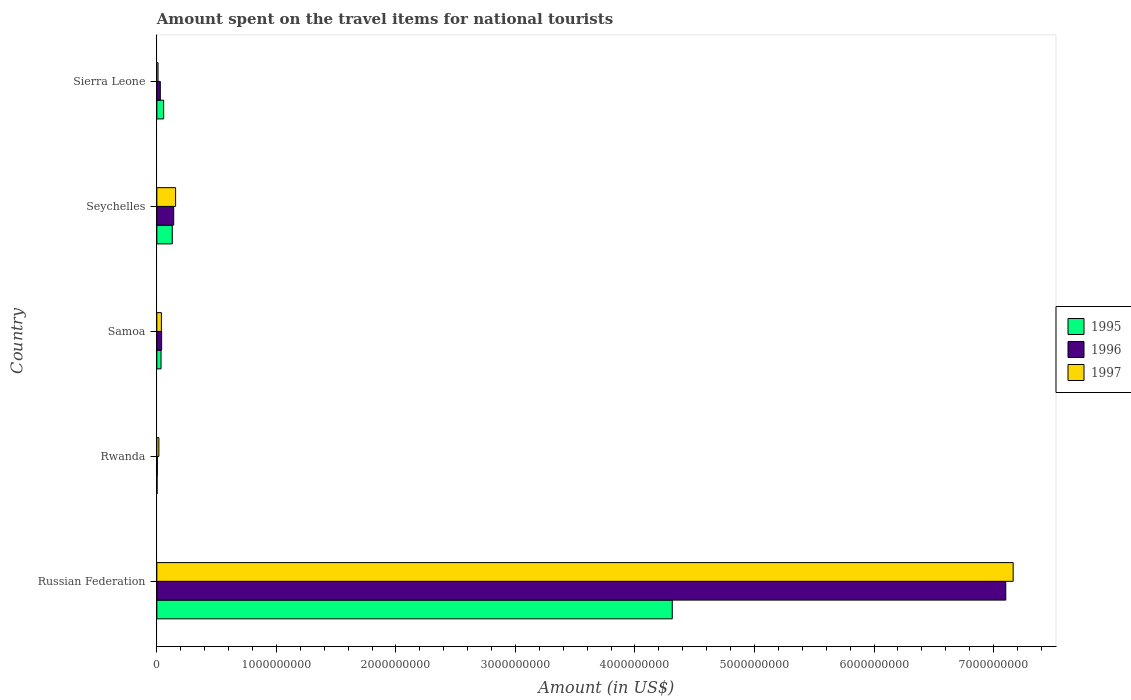What is the label of the 5th group of bars from the top?
Offer a very short reply. Russian Federation. What is the amount spent on the travel items for national tourists in 1996 in Seychelles?
Provide a short and direct response. 1.41e+08. Across all countries, what is the maximum amount spent on the travel items for national tourists in 1995?
Your response must be concise. 4.31e+09. Across all countries, what is the minimum amount spent on the travel items for national tourists in 1996?
Ensure brevity in your answer.  4.00e+06. In which country was the amount spent on the travel items for national tourists in 1995 maximum?
Make the answer very short. Russian Federation. In which country was the amount spent on the travel items for national tourists in 1996 minimum?
Your answer should be compact. Rwanda. What is the total amount spent on the travel items for national tourists in 1995 in the graph?
Make the answer very short. 4.54e+09. What is the difference between the amount spent on the travel items for national tourists in 1997 in Seychelles and that in Sierra Leone?
Your answer should be compact. 1.47e+08. What is the difference between the amount spent on the travel items for national tourists in 1997 in Samoa and the amount spent on the travel items for national tourists in 1996 in Seychelles?
Make the answer very short. -1.03e+08. What is the average amount spent on the travel items for national tourists in 1997 per country?
Your answer should be very brief. 1.48e+09. What is the difference between the amount spent on the travel items for national tourists in 1996 and amount spent on the travel items for national tourists in 1997 in Rwanda?
Your answer should be very brief. -1.30e+07. What is the ratio of the amount spent on the travel items for national tourists in 1996 in Russian Federation to that in Seychelles?
Offer a terse response. 50.37. What is the difference between the highest and the second highest amount spent on the travel items for national tourists in 1997?
Give a very brief answer. 7.01e+09. What is the difference between the highest and the lowest amount spent on the travel items for national tourists in 1995?
Provide a short and direct response. 4.31e+09. In how many countries, is the amount spent on the travel items for national tourists in 1997 greater than the average amount spent on the travel items for national tourists in 1997 taken over all countries?
Your answer should be compact. 1. Is the sum of the amount spent on the travel items for national tourists in 1996 in Russian Federation and Rwanda greater than the maximum amount spent on the travel items for national tourists in 1995 across all countries?
Your answer should be compact. Yes. What does the 2nd bar from the top in Seychelles represents?
Your answer should be very brief. 1996. What does the 2nd bar from the bottom in Samoa represents?
Your response must be concise. 1996. Is it the case that in every country, the sum of the amount spent on the travel items for national tourists in 1996 and amount spent on the travel items for national tourists in 1997 is greater than the amount spent on the travel items for national tourists in 1995?
Your answer should be very brief. No. Are all the bars in the graph horizontal?
Your answer should be very brief. Yes. Are the values on the major ticks of X-axis written in scientific E-notation?
Your response must be concise. No. How many legend labels are there?
Ensure brevity in your answer.  3. What is the title of the graph?
Offer a terse response. Amount spent on the travel items for national tourists. What is the Amount (in US$) of 1995 in Russian Federation?
Ensure brevity in your answer.  4.31e+09. What is the Amount (in US$) of 1996 in Russian Federation?
Your answer should be compact. 7.10e+09. What is the Amount (in US$) of 1997 in Russian Federation?
Provide a short and direct response. 7.16e+09. What is the Amount (in US$) in 1995 in Rwanda?
Make the answer very short. 2.00e+06. What is the Amount (in US$) of 1997 in Rwanda?
Your answer should be compact. 1.70e+07. What is the Amount (in US$) in 1995 in Samoa?
Give a very brief answer. 3.50e+07. What is the Amount (in US$) in 1996 in Samoa?
Make the answer very short. 4.00e+07. What is the Amount (in US$) in 1997 in Samoa?
Your answer should be compact. 3.80e+07. What is the Amount (in US$) of 1995 in Seychelles?
Provide a short and direct response. 1.29e+08. What is the Amount (in US$) in 1996 in Seychelles?
Your answer should be very brief. 1.41e+08. What is the Amount (in US$) of 1997 in Seychelles?
Give a very brief answer. 1.57e+08. What is the Amount (in US$) of 1995 in Sierra Leone?
Provide a short and direct response. 5.70e+07. What is the Amount (in US$) of 1996 in Sierra Leone?
Your answer should be compact. 2.90e+07. Across all countries, what is the maximum Amount (in US$) of 1995?
Your response must be concise. 4.31e+09. Across all countries, what is the maximum Amount (in US$) of 1996?
Your answer should be compact. 7.10e+09. Across all countries, what is the maximum Amount (in US$) in 1997?
Give a very brief answer. 7.16e+09. Across all countries, what is the minimum Amount (in US$) of 1996?
Ensure brevity in your answer.  4.00e+06. What is the total Amount (in US$) in 1995 in the graph?
Provide a short and direct response. 4.54e+09. What is the total Amount (in US$) of 1996 in the graph?
Provide a succinct answer. 7.32e+09. What is the total Amount (in US$) in 1997 in the graph?
Your response must be concise. 7.39e+09. What is the difference between the Amount (in US$) in 1995 in Russian Federation and that in Rwanda?
Provide a succinct answer. 4.31e+09. What is the difference between the Amount (in US$) in 1996 in Russian Federation and that in Rwanda?
Make the answer very short. 7.10e+09. What is the difference between the Amount (in US$) in 1997 in Russian Federation and that in Rwanda?
Keep it short and to the point. 7.15e+09. What is the difference between the Amount (in US$) in 1995 in Russian Federation and that in Samoa?
Your response must be concise. 4.28e+09. What is the difference between the Amount (in US$) in 1996 in Russian Federation and that in Samoa?
Give a very brief answer. 7.06e+09. What is the difference between the Amount (in US$) of 1997 in Russian Federation and that in Samoa?
Provide a short and direct response. 7.13e+09. What is the difference between the Amount (in US$) of 1995 in Russian Federation and that in Seychelles?
Provide a short and direct response. 4.18e+09. What is the difference between the Amount (in US$) of 1996 in Russian Federation and that in Seychelles?
Ensure brevity in your answer.  6.96e+09. What is the difference between the Amount (in US$) in 1997 in Russian Federation and that in Seychelles?
Keep it short and to the point. 7.01e+09. What is the difference between the Amount (in US$) in 1995 in Russian Federation and that in Sierra Leone?
Give a very brief answer. 4.26e+09. What is the difference between the Amount (in US$) of 1996 in Russian Federation and that in Sierra Leone?
Provide a short and direct response. 7.07e+09. What is the difference between the Amount (in US$) in 1997 in Russian Federation and that in Sierra Leone?
Offer a very short reply. 7.15e+09. What is the difference between the Amount (in US$) in 1995 in Rwanda and that in Samoa?
Make the answer very short. -3.30e+07. What is the difference between the Amount (in US$) of 1996 in Rwanda and that in Samoa?
Your answer should be very brief. -3.60e+07. What is the difference between the Amount (in US$) of 1997 in Rwanda and that in Samoa?
Provide a succinct answer. -2.10e+07. What is the difference between the Amount (in US$) of 1995 in Rwanda and that in Seychelles?
Keep it short and to the point. -1.27e+08. What is the difference between the Amount (in US$) of 1996 in Rwanda and that in Seychelles?
Give a very brief answer. -1.37e+08. What is the difference between the Amount (in US$) in 1997 in Rwanda and that in Seychelles?
Provide a succinct answer. -1.40e+08. What is the difference between the Amount (in US$) of 1995 in Rwanda and that in Sierra Leone?
Give a very brief answer. -5.50e+07. What is the difference between the Amount (in US$) in 1996 in Rwanda and that in Sierra Leone?
Your response must be concise. -2.50e+07. What is the difference between the Amount (in US$) of 1995 in Samoa and that in Seychelles?
Offer a terse response. -9.40e+07. What is the difference between the Amount (in US$) in 1996 in Samoa and that in Seychelles?
Your answer should be very brief. -1.01e+08. What is the difference between the Amount (in US$) in 1997 in Samoa and that in Seychelles?
Give a very brief answer. -1.19e+08. What is the difference between the Amount (in US$) in 1995 in Samoa and that in Sierra Leone?
Offer a terse response. -2.20e+07. What is the difference between the Amount (in US$) in 1996 in Samoa and that in Sierra Leone?
Offer a terse response. 1.10e+07. What is the difference between the Amount (in US$) in 1997 in Samoa and that in Sierra Leone?
Offer a terse response. 2.80e+07. What is the difference between the Amount (in US$) in 1995 in Seychelles and that in Sierra Leone?
Keep it short and to the point. 7.20e+07. What is the difference between the Amount (in US$) of 1996 in Seychelles and that in Sierra Leone?
Your answer should be compact. 1.12e+08. What is the difference between the Amount (in US$) in 1997 in Seychelles and that in Sierra Leone?
Offer a very short reply. 1.47e+08. What is the difference between the Amount (in US$) in 1995 in Russian Federation and the Amount (in US$) in 1996 in Rwanda?
Give a very brief answer. 4.31e+09. What is the difference between the Amount (in US$) of 1995 in Russian Federation and the Amount (in US$) of 1997 in Rwanda?
Provide a succinct answer. 4.30e+09. What is the difference between the Amount (in US$) in 1996 in Russian Federation and the Amount (in US$) in 1997 in Rwanda?
Offer a terse response. 7.08e+09. What is the difference between the Amount (in US$) in 1995 in Russian Federation and the Amount (in US$) in 1996 in Samoa?
Offer a very short reply. 4.27e+09. What is the difference between the Amount (in US$) of 1995 in Russian Federation and the Amount (in US$) of 1997 in Samoa?
Your answer should be very brief. 4.27e+09. What is the difference between the Amount (in US$) of 1996 in Russian Federation and the Amount (in US$) of 1997 in Samoa?
Keep it short and to the point. 7.06e+09. What is the difference between the Amount (in US$) in 1995 in Russian Federation and the Amount (in US$) in 1996 in Seychelles?
Ensure brevity in your answer.  4.17e+09. What is the difference between the Amount (in US$) in 1995 in Russian Federation and the Amount (in US$) in 1997 in Seychelles?
Offer a very short reply. 4.16e+09. What is the difference between the Amount (in US$) in 1996 in Russian Federation and the Amount (in US$) in 1997 in Seychelles?
Ensure brevity in your answer.  6.94e+09. What is the difference between the Amount (in US$) in 1995 in Russian Federation and the Amount (in US$) in 1996 in Sierra Leone?
Your answer should be compact. 4.28e+09. What is the difference between the Amount (in US$) in 1995 in Russian Federation and the Amount (in US$) in 1997 in Sierra Leone?
Make the answer very short. 4.30e+09. What is the difference between the Amount (in US$) of 1996 in Russian Federation and the Amount (in US$) of 1997 in Sierra Leone?
Your answer should be compact. 7.09e+09. What is the difference between the Amount (in US$) in 1995 in Rwanda and the Amount (in US$) in 1996 in Samoa?
Offer a very short reply. -3.80e+07. What is the difference between the Amount (in US$) of 1995 in Rwanda and the Amount (in US$) of 1997 in Samoa?
Give a very brief answer. -3.60e+07. What is the difference between the Amount (in US$) in 1996 in Rwanda and the Amount (in US$) in 1997 in Samoa?
Provide a succinct answer. -3.40e+07. What is the difference between the Amount (in US$) of 1995 in Rwanda and the Amount (in US$) of 1996 in Seychelles?
Provide a short and direct response. -1.39e+08. What is the difference between the Amount (in US$) of 1995 in Rwanda and the Amount (in US$) of 1997 in Seychelles?
Keep it short and to the point. -1.55e+08. What is the difference between the Amount (in US$) of 1996 in Rwanda and the Amount (in US$) of 1997 in Seychelles?
Ensure brevity in your answer.  -1.53e+08. What is the difference between the Amount (in US$) of 1995 in Rwanda and the Amount (in US$) of 1996 in Sierra Leone?
Keep it short and to the point. -2.70e+07. What is the difference between the Amount (in US$) in 1995 in Rwanda and the Amount (in US$) in 1997 in Sierra Leone?
Offer a terse response. -8.00e+06. What is the difference between the Amount (in US$) of 1996 in Rwanda and the Amount (in US$) of 1997 in Sierra Leone?
Ensure brevity in your answer.  -6.00e+06. What is the difference between the Amount (in US$) of 1995 in Samoa and the Amount (in US$) of 1996 in Seychelles?
Provide a succinct answer. -1.06e+08. What is the difference between the Amount (in US$) of 1995 in Samoa and the Amount (in US$) of 1997 in Seychelles?
Your answer should be compact. -1.22e+08. What is the difference between the Amount (in US$) in 1996 in Samoa and the Amount (in US$) in 1997 in Seychelles?
Give a very brief answer. -1.17e+08. What is the difference between the Amount (in US$) in 1995 in Samoa and the Amount (in US$) in 1996 in Sierra Leone?
Your answer should be very brief. 6.00e+06. What is the difference between the Amount (in US$) in 1995 in Samoa and the Amount (in US$) in 1997 in Sierra Leone?
Your answer should be very brief. 2.50e+07. What is the difference between the Amount (in US$) in 1996 in Samoa and the Amount (in US$) in 1997 in Sierra Leone?
Your response must be concise. 3.00e+07. What is the difference between the Amount (in US$) in 1995 in Seychelles and the Amount (in US$) in 1997 in Sierra Leone?
Your answer should be compact. 1.19e+08. What is the difference between the Amount (in US$) of 1996 in Seychelles and the Amount (in US$) of 1997 in Sierra Leone?
Keep it short and to the point. 1.31e+08. What is the average Amount (in US$) of 1995 per country?
Make the answer very short. 9.07e+08. What is the average Amount (in US$) in 1996 per country?
Offer a very short reply. 1.46e+09. What is the average Amount (in US$) in 1997 per country?
Your response must be concise. 1.48e+09. What is the difference between the Amount (in US$) in 1995 and Amount (in US$) in 1996 in Russian Federation?
Your answer should be compact. -2.79e+09. What is the difference between the Amount (in US$) of 1995 and Amount (in US$) of 1997 in Russian Federation?
Provide a short and direct response. -2.85e+09. What is the difference between the Amount (in US$) of 1996 and Amount (in US$) of 1997 in Russian Federation?
Ensure brevity in your answer.  -6.20e+07. What is the difference between the Amount (in US$) of 1995 and Amount (in US$) of 1996 in Rwanda?
Your answer should be compact. -2.00e+06. What is the difference between the Amount (in US$) in 1995 and Amount (in US$) in 1997 in Rwanda?
Keep it short and to the point. -1.50e+07. What is the difference between the Amount (in US$) in 1996 and Amount (in US$) in 1997 in Rwanda?
Provide a succinct answer. -1.30e+07. What is the difference between the Amount (in US$) in 1995 and Amount (in US$) in 1996 in Samoa?
Offer a very short reply. -5.00e+06. What is the difference between the Amount (in US$) in 1995 and Amount (in US$) in 1996 in Seychelles?
Give a very brief answer. -1.20e+07. What is the difference between the Amount (in US$) in 1995 and Amount (in US$) in 1997 in Seychelles?
Give a very brief answer. -2.80e+07. What is the difference between the Amount (in US$) of 1996 and Amount (in US$) of 1997 in Seychelles?
Provide a succinct answer. -1.60e+07. What is the difference between the Amount (in US$) in 1995 and Amount (in US$) in 1996 in Sierra Leone?
Your answer should be very brief. 2.80e+07. What is the difference between the Amount (in US$) in 1995 and Amount (in US$) in 1997 in Sierra Leone?
Provide a succinct answer. 4.70e+07. What is the difference between the Amount (in US$) in 1996 and Amount (in US$) in 1997 in Sierra Leone?
Ensure brevity in your answer.  1.90e+07. What is the ratio of the Amount (in US$) of 1995 in Russian Federation to that in Rwanda?
Keep it short and to the point. 2156. What is the ratio of the Amount (in US$) of 1996 in Russian Federation to that in Rwanda?
Your answer should be compact. 1775.5. What is the ratio of the Amount (in US$) in 1997 in Russian Federation to that in Rwanda?
Your answer should be compact. 421.41. What is the ratio of the Amount (in US$) of 1995 in Russian Federation to that in Samoa?
Your answer should be compact. 123.2. What is the ratio of the Amount (in US$) in 1996 in Russian Federation to that in Samoa?
Make the answer very short. 177.55. What is the ratio of the Amount (in US$) in 1997 in Russian Federation to that in Samoa?
Your answer should be very brief. 188.53. What is the ratio of the Amount (in US$) in 1995 in Russian Federation to that in Seychelles?
Your answer should be compact. 33.43. What is the ratio of the Amount (in US$) of 1996 in Russian Federation to that in Seychelles?
Ensure brevity in your answer.  50.37. What is the ratio of the Amount (in US$) of 1997 in Russian Federation to that in Seychelles?
Offer a very short reply. 45.63. What is the ratio of the Amount (in US$) in 1995 in Russian Federation to that in Sierra Leone?
Your response must be concise. 75.65. What is the ratio of the Amount (in US$) in 1996 in Russian Federation to that in Sierra Leone?
Provide a short and direct response. 244.9. What is the ratio of the Amount (in US$) of 1997 in Russian Federation to that in Sierra Leone?
Ensure brevity in your answer.  716.4. What is the ratio of the Amount (in US$) in 1995 in Rwanda to that in Samoa?
Your answer should be very brief. 0.06. What is the ratio of the Amount (in US$) in 1997 in Rwanda to that in Samoa?
Give a very brief answer. 0.45. What is the ratio of the Amount (in US$) in 1995 in Rwanda to that in Seychelles?
Make the answer very short. 0.02. What is the ratio of the Amount (in US$) of 1996 in Rwanda to that in Seychelles?
Give a very brief answer. 0.03. What is the ratio of the Amount (in US$) in 1997 in Rwanda to that in Seychelles?
Your response must be concise. 0.11. What is the ratio of the Amount (in US$) in 1995 in Rwanda to that in Sierra Leone?
Keep it short and to the point. 0.04. What is the ratio of the Amount (in US$) in 1996 in Rwanda to that in Sierra Leone?
Your answer should be very brief. 0.14. What is the ratio of the Amount (in US$) of 1995 in Samoa to that in Seychelles?
Offer a terse response. 0.27. What is the ratio of the Amount (in US$) in 1996 in Samoa to that in Seychelles?
Provide a succinct answer. 0.28. What is the ratio of the Amount (in US$) of 1997 in Samoa to that in Seychelles?
Your answer should be very brief. 0.24. What is the ratio of the Amount (in US$) of 1995 in Samoa to that in Sierra Leone?
Provide a short and direct response. 0.61. What is the ratio of the Amount (in US$) of 1996 in Samoa to that in Sierra Leone?
Your answer should be very brief. 1.38. What is the ratio of the Amount (in US$) in 1995 in Seychelles to that in Sierra Leone?
Give a very brief answer. 2.26. What is the ratio of the Amount (in US$) in 1996 in Seychelles to that in Sierra Leone?
Your answer should be compact. 4.86. What is the difference between the highest and the second highest Amount (in US$) of 1995?
Your answer should be very brief. 4.18e+09. What is the difference between the highest and the second highest Amount (in US$) of 1996?
Make the answer very short. 6.96e+09. What is the difference between the highest and the second highest Amount (in US$) of 1997?
Your answer should be very brief. 7.01e+09. What is the difference between the highest and the lowest Amount (in US$) in 1995?
Provide a succinct answer. 4.31e+09. What is the difference between the highest and the lowest Amount (in US$) of 1996?
Provide a succinct answer. 7.10e+09. What is the difference between the highest and the lowest Amount (in US$) of 1997?
Ensure brevity in your answer.  7.15e+09. 